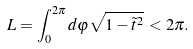<formula> <loc_0><loc_0><loc_500><loc_500>L = \int _ { 0 } ^ { 2 \pi } { d \varphi \sqrt { 1 - \tilde { t } ^ { 2 } } } \, < 2 \pi .</formula> 